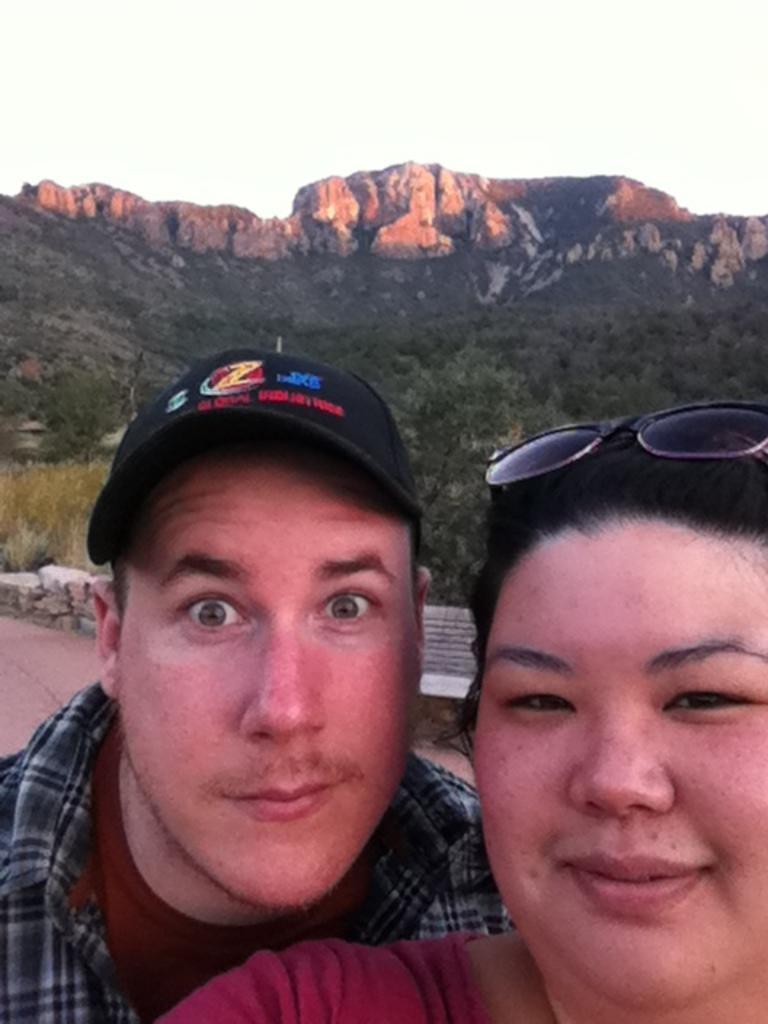How would you summarize this image in a sentence or two? In this image I can see two people with different color dresses. In the background I can see the rock's, many trees, mountains and the sky. 